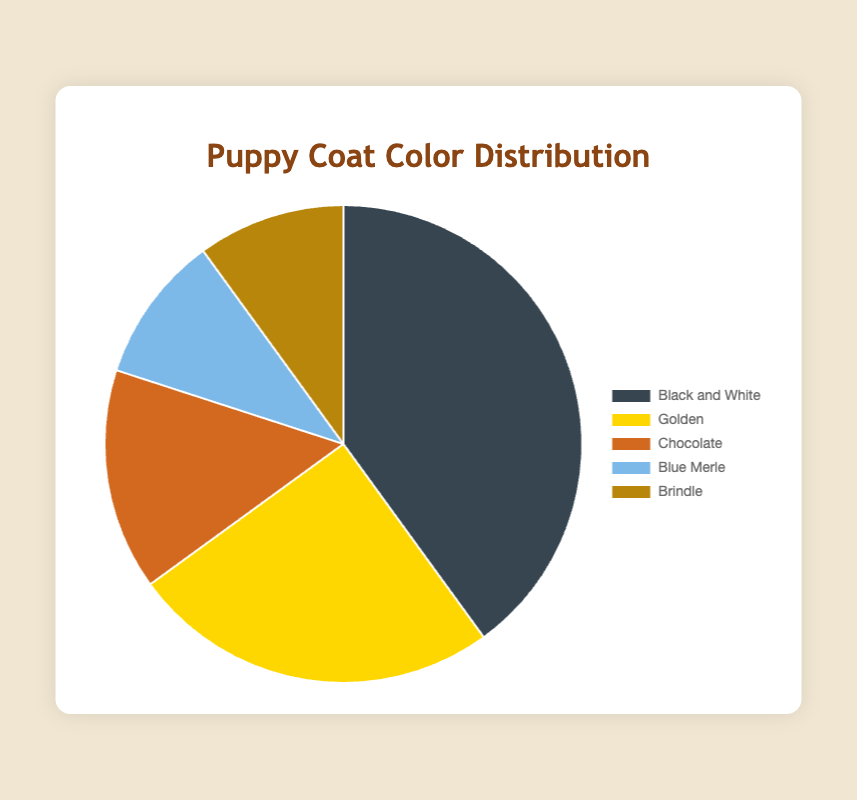What percentage of puppies have a Brindle coat? The Pie chart shows different coat colors and their respective percentages. From the chart, the percentage of puppies with a Brindle coat is labeled.
Answer: 10% Which coat color has the highest percentage of puppies? By observing the Pie chart, we can compare the sizes of the slices which correspond to different coat colors. The largest slice represents the coat color with the highest percentage.
Answer: Black and White How much more common is the Golden coat compared to the Blue Merle coat? To find how much more common the Golden coat is compared to the Blue Merle coat, we subtract the Blue Merle percentage from the Golden percentage. Golden (25%) - Blue Merle (10%) = 15%.
Answer: 15% What are the combined percentages of Chocolate and Brindle coat colors? The Pie chart shows the percentages for each coat color. To find the combined percentage of two colors, simply add their individual percentages: Chocolate (15%) + Brindle (10%) = 25%.
Answer: 25% How does the percentage of Chocolate compare with that of Golden coat color? By looking at the Pie chart, we can directly compare the percentages for Chocolate and Golden colors. The Golden coat has a higher percentage than the Chocolate coat. Golden: 25%, Chocolate: 15%. 25% is greater than 15%.
Answer: Golden > Chocolate What is the least common puppy coat color in this litter? Reviewing the Pie chart, the smallest section indicates the least common coat color among the puppies.
Answer: Blue Merle or Brindle If there are 20 puppies in the litter, how many have a Black and White coat? To find the number of puppies with a specific coat color, multiply the total number of puppies by the percentage of that coat color: 20 (total puppies) * 0.4 (Black and White percentage / 100) = 8 puppies.
Answer: 8 What is the average percentage of the coat colors? To calculate the average percentage, sum all the percentages and divide by the number of coat colors: (40% + 25% + 15% + 10% + 10%) / 5 = 20%.
Answer: 20% Compare the percentage of puppies with a Blue Merle coat to those with a Brindle coat. Observing the Pie chart, both Blue Merle and Brindle have equal slices, indicating they both have the same percentage.
Answer: Equal or 10% 